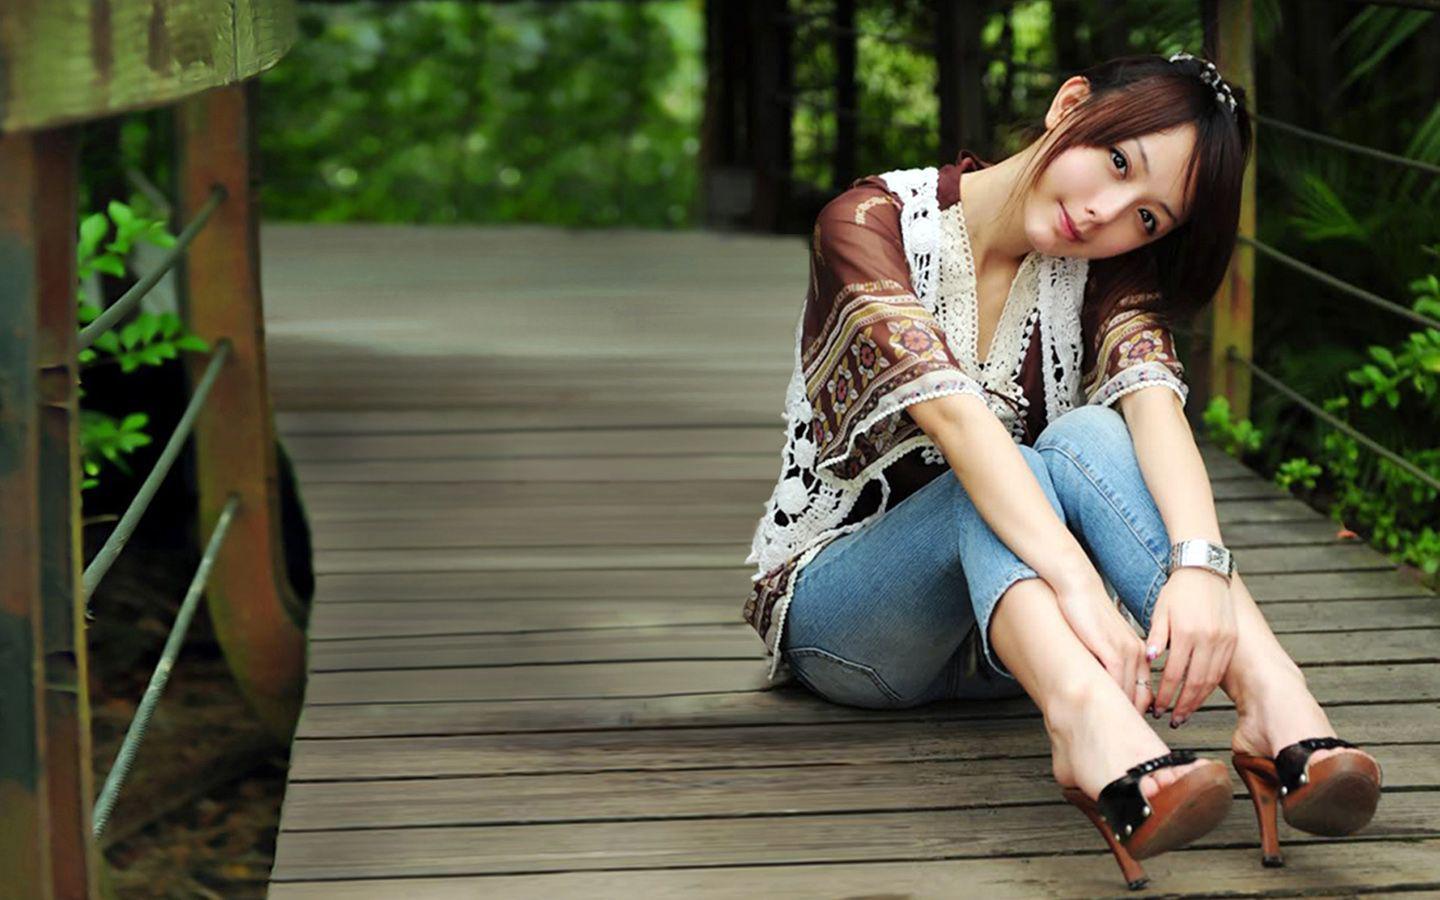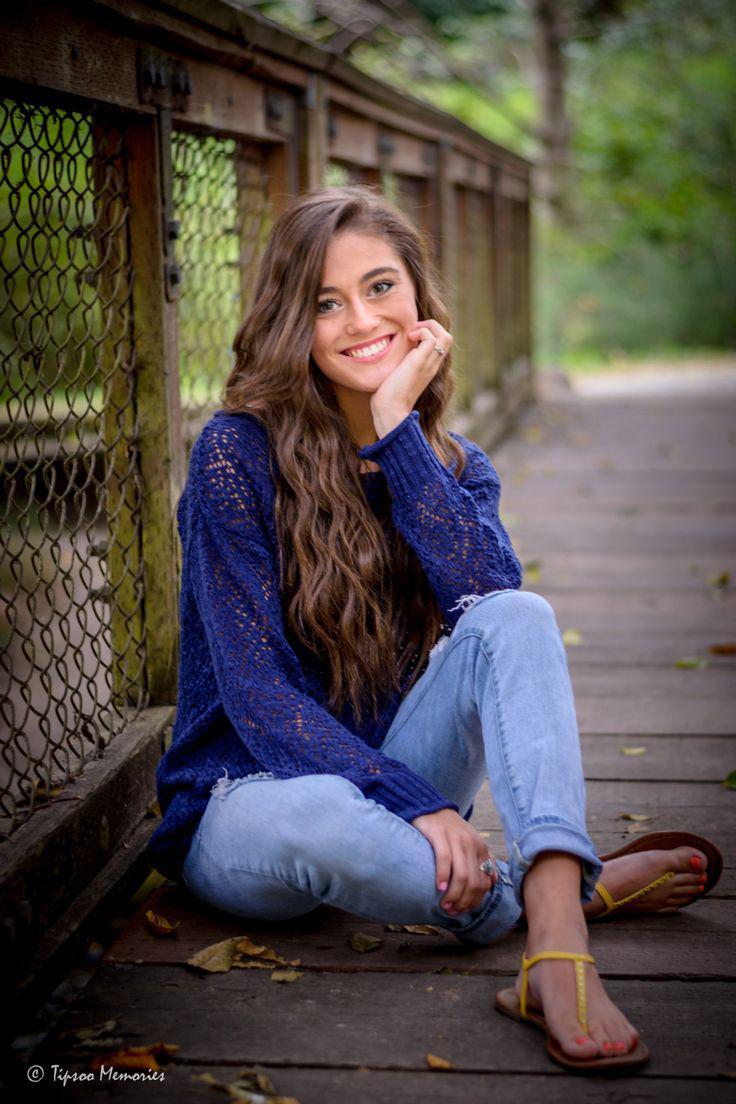The first image is the image on the left, the second image is the image on the right. Evaluate the accuracy of this statement regarding the images: "In one image is a pair of girls together and the other image is one single girl.". Is it true? Answer yes or no. No. The first image is the image on the left, the second image is the image on the right. Evaluate the accuracy of this statement regarding the images: "One image shows exactly one girl standing and leaning with her arms on a rail, and smiling at the camera.". Is it true? Answer yes or no. No. 